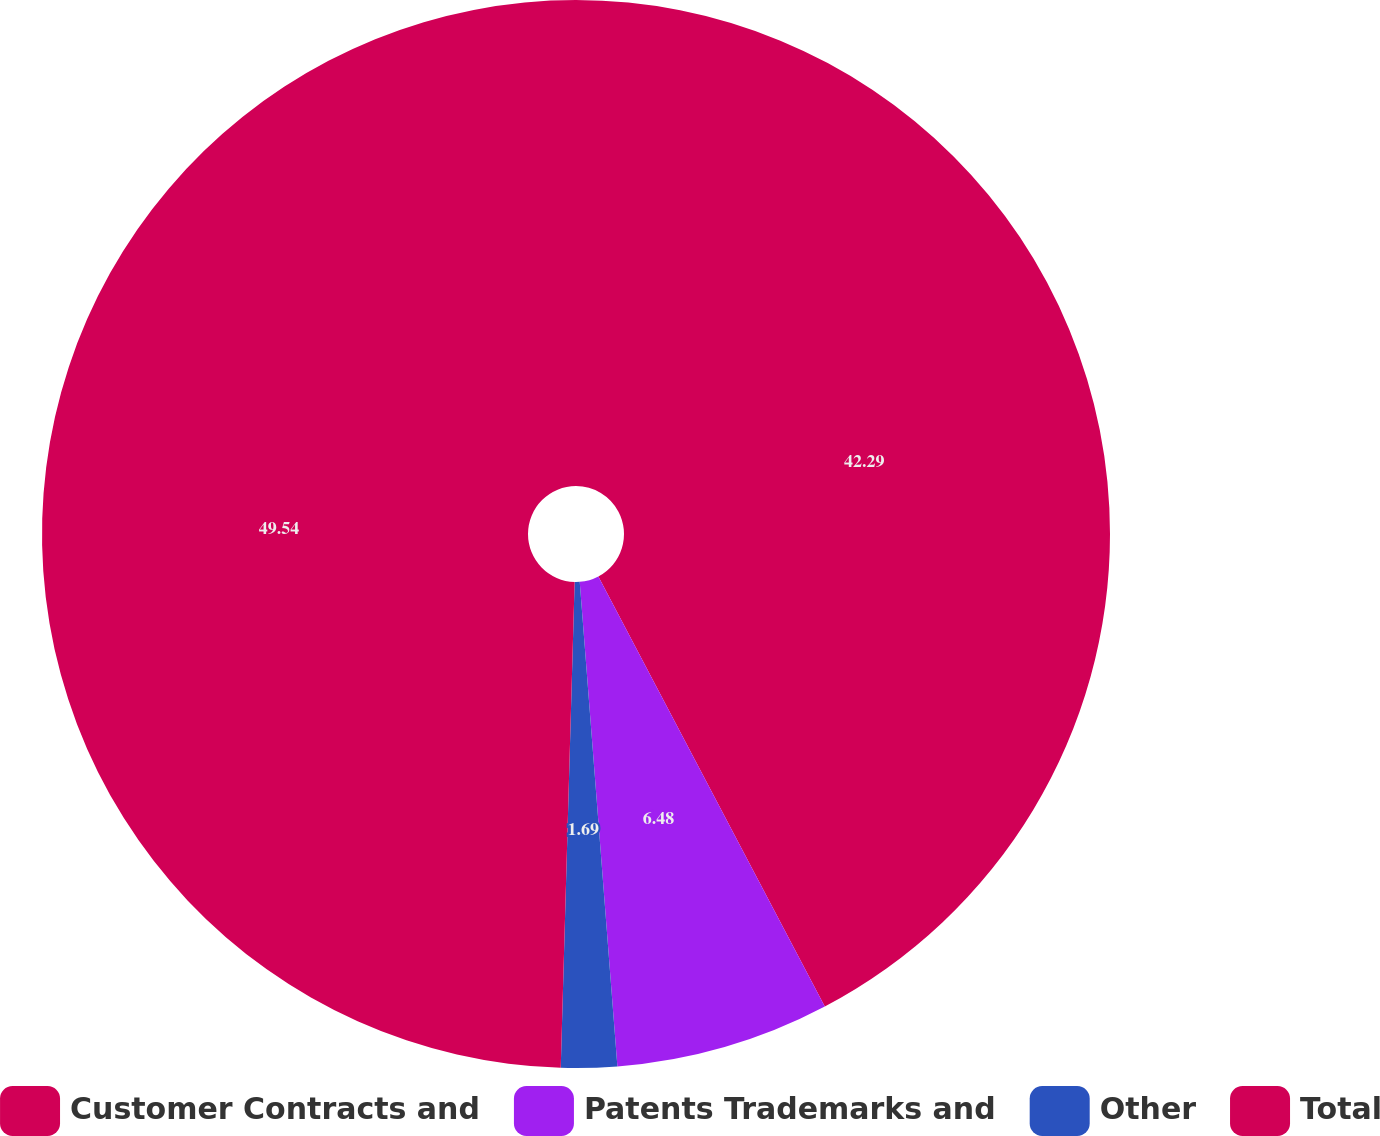<chart> <loc_0><loc_0><loc_500><loc_500><pie_chart><fcel>Customer Contracts and<fcel>Patents Trademarks and<fcel>Other<fcel>Total<nl><fcel>42.29%<fcel>6.48%<fcel>1.69%<fcel>49.55%<nl></chart> 